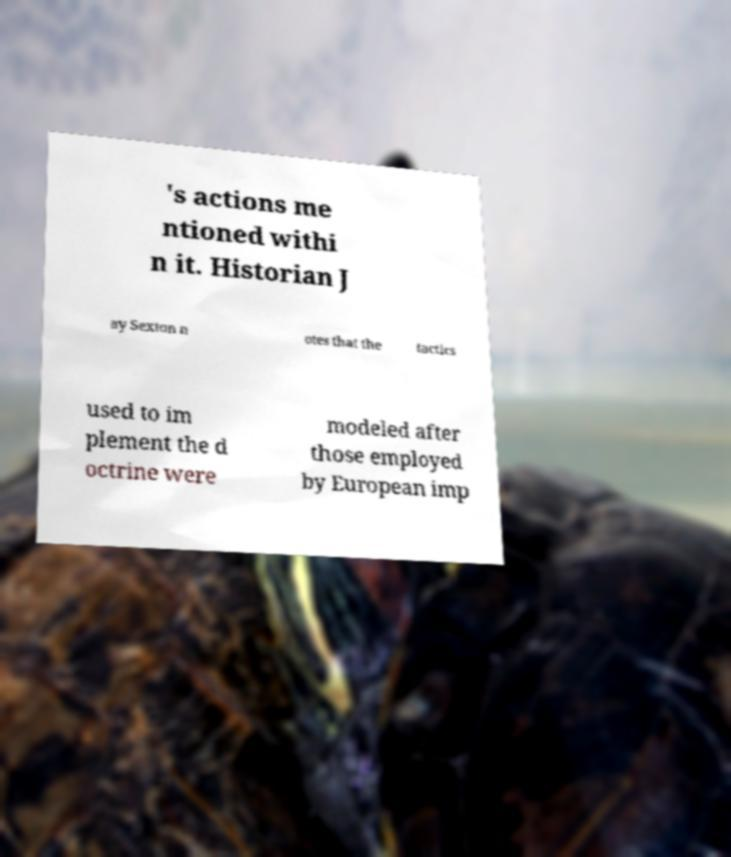For documentation purposes, I need the text within this image transcribed. Could you provide that? 's actions me ntioned withi n it. Historian J ay Sexton n otes that the tactics used to im plement the d octrine were modeled after those employed by European imp 